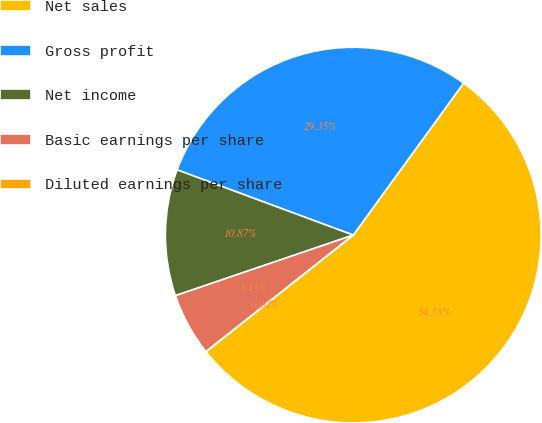Convert chart to OTSL. <chart><loc_0><loc_0><loc_500><loc_500><pie_chart><fcel>Net sales<fcel>Gross profit<fcel>Net income<fcel>Basic earnings per share<fcel>Diluted earnings per share<nl><fcel>54.35%<fcel>29.35%<fcel>10.87%<fcel>5.43%<fcel>0.0%<nl></chart> 